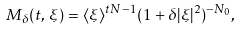<formula> <loc_0><loc_0><loc_500><loc_500>M _ { \delta } ( t , \, \xi ) = \langle \xi \rangle ^ { t N - 1 } ( 1 + \delta | \xi | ^ { 2 } ) ^ { - N _ { 0 } } ,</formula> 